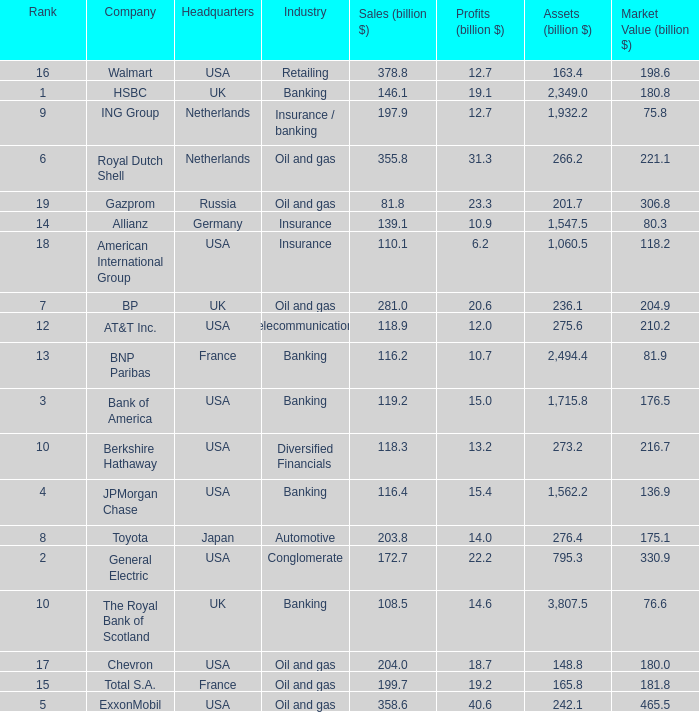What is the amount of profits in billions for companies with a market value of 204.9 billion?  20.6. I'm looking to parse the entire table for insights. Could you assist me with that? {'header': ['Rank', 'Company', 'Headquarters', 'Industry', 'Sales (billion $)', 'Profits (billion $)', 'Assets (billion $)', 'Market Value (billion $)'], 'rows': [['16', 'Walmart', 'USA', 'Retailing', '378.8', '12.7', '163.4', '198.6'], ['1', 'HSBC', 'UK', 'Banking', '146.1', '19.1', '2,349.0', '180.8'], ['9', 'ING Group', 'Netherlands', 'Insurance / banking', '197.9', '12.7', '1,932.2', '75.8'], ['6', 'Royal Dutch Shell', 'Netherlands', 'Oil and gas', '355.8', '31.3', '266.2', '221.1'], ['19', 'Gazprom', 'Russia', 'Oil and gas', '81.8', '23.3', '201.7', '306.8'], ['14', 'Allianz', 'Germany', 'Insurance', '139.1', '10.9', '1,547.5', '80.3'], ['18', 'American International Group', 'USA', 'Insurance', '110.1', '6.2', '1,060.5', '118.2'], ['7', 'BP', 'UK', 'Oil and gas', '281.0', '20.6', '236.1', '204.9'], ['12', 'AT&T Inc.', 'USA', 'Telecommunications', '118.9', '12.0', '275.6', '210.2'], ['13', 'BNP Paribas', 'France', 'Banking', '116.2', '10.7', '2,494.4', '81.9'], ['3', 'Bank of America', 'USA', 'Banking', '119.2', '15.0', '1,715.8', '176.5'], ['10', 'Berkshire Hathaway', 'USA', 'Diversified Financials', '118.3', '13.2', '273.2', '216.7'], ['4', 'JPMorgan Chase', 'USA', 'Banking', '116.4', '15.4', '1,562.2', '136.9'], ['8', 'Toyota', 'Japan', 'Automotive', '203.8', '14.0', '276.4', '175.1'], ['2', 'General Electric', 'USA', 'Conglomerate', '172.7', '22.2', '795.3', '330.9'], ['10', 'The Royal Bank of Scotland', 'UK', 'Banking', '108.5', '14.6', '3,807.5', '76.6'], ['17', 'Chevron', 'USA', 'Oil and gas', '204.0', '18.7', '148.8', '180.0'], ['15', 'Total S.A.', 'France', 'Oil and gas', '199.7', '19.2', '165.8', '181.8'], ['5', 'ExxonMobil', 'USA', 'Oil and gas', '358.6', '40.6', '242.1', '465.5']]} 